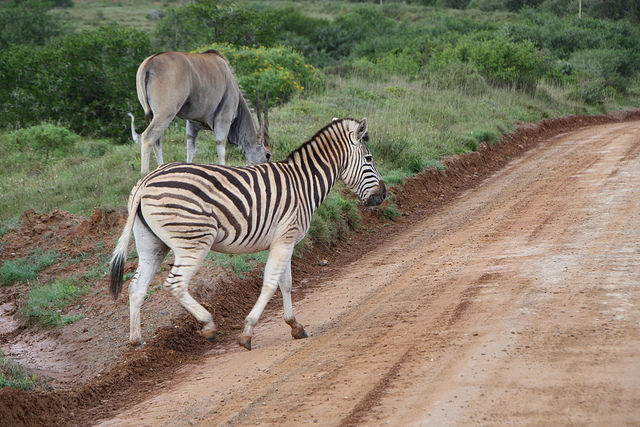Can you describe the environment in which these animals are found? Certainly! The environment looks like a savanna ecosystem, characterized by its grassy plains with sporadic trees and shrubs, visible in the background. Such landscapes are typical in sub-Saharan Africa and are home to a diverse range of wildlife, including zebras and various species of antelope. The dirt path indicates that this area may be used for guided safari tours, allowing visitors to observe wildlife in their natural habitat while minimizing disturbance to the ecosystem. 